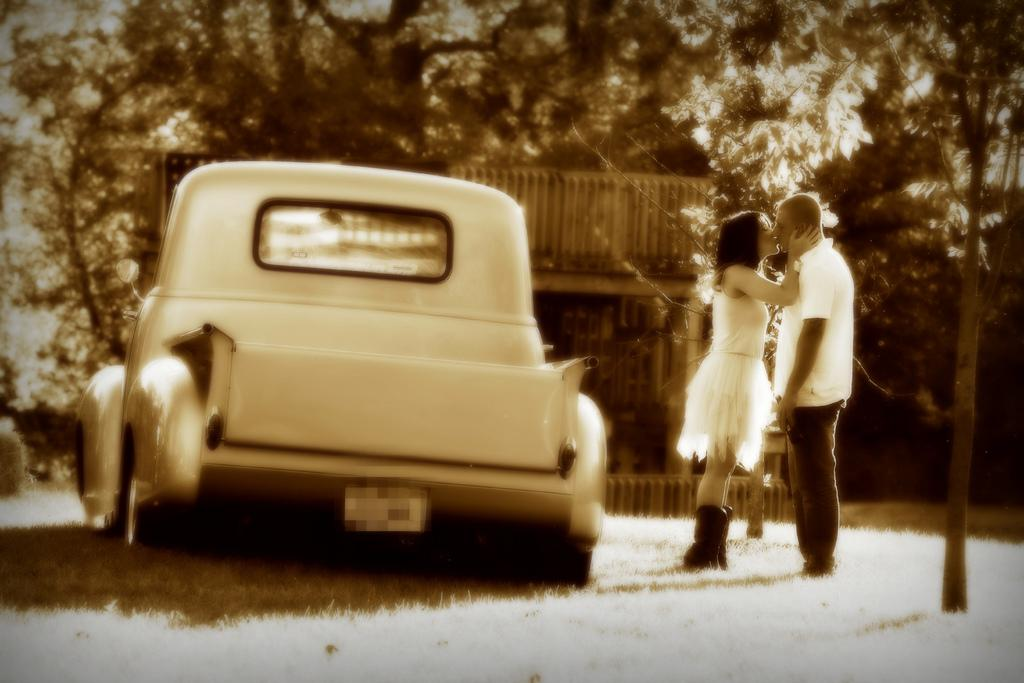What type of vegetation is present in the image? There is grass in the image. What type of vehicle is visible in the image? There is a car in the image. What other natural elements can be seen in the image? There are trees in the image. How many people are present in the image? Two persons are standing in the image. How many lizards are sitting on the car in the image? There are no lizards present in the image; only grass, trees, a car, and two persons can be seen. What type of fruit is being held by one of the persons in the image? There is no fruit visible in the image, and it is not mentioned that one of the persons is holding anything. 